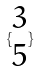<formula> <loc_0><loc_0><loc_500><loc_500>\{ \begin{matrix} 3 \\ 5 \end{matrix} \}</formula> 